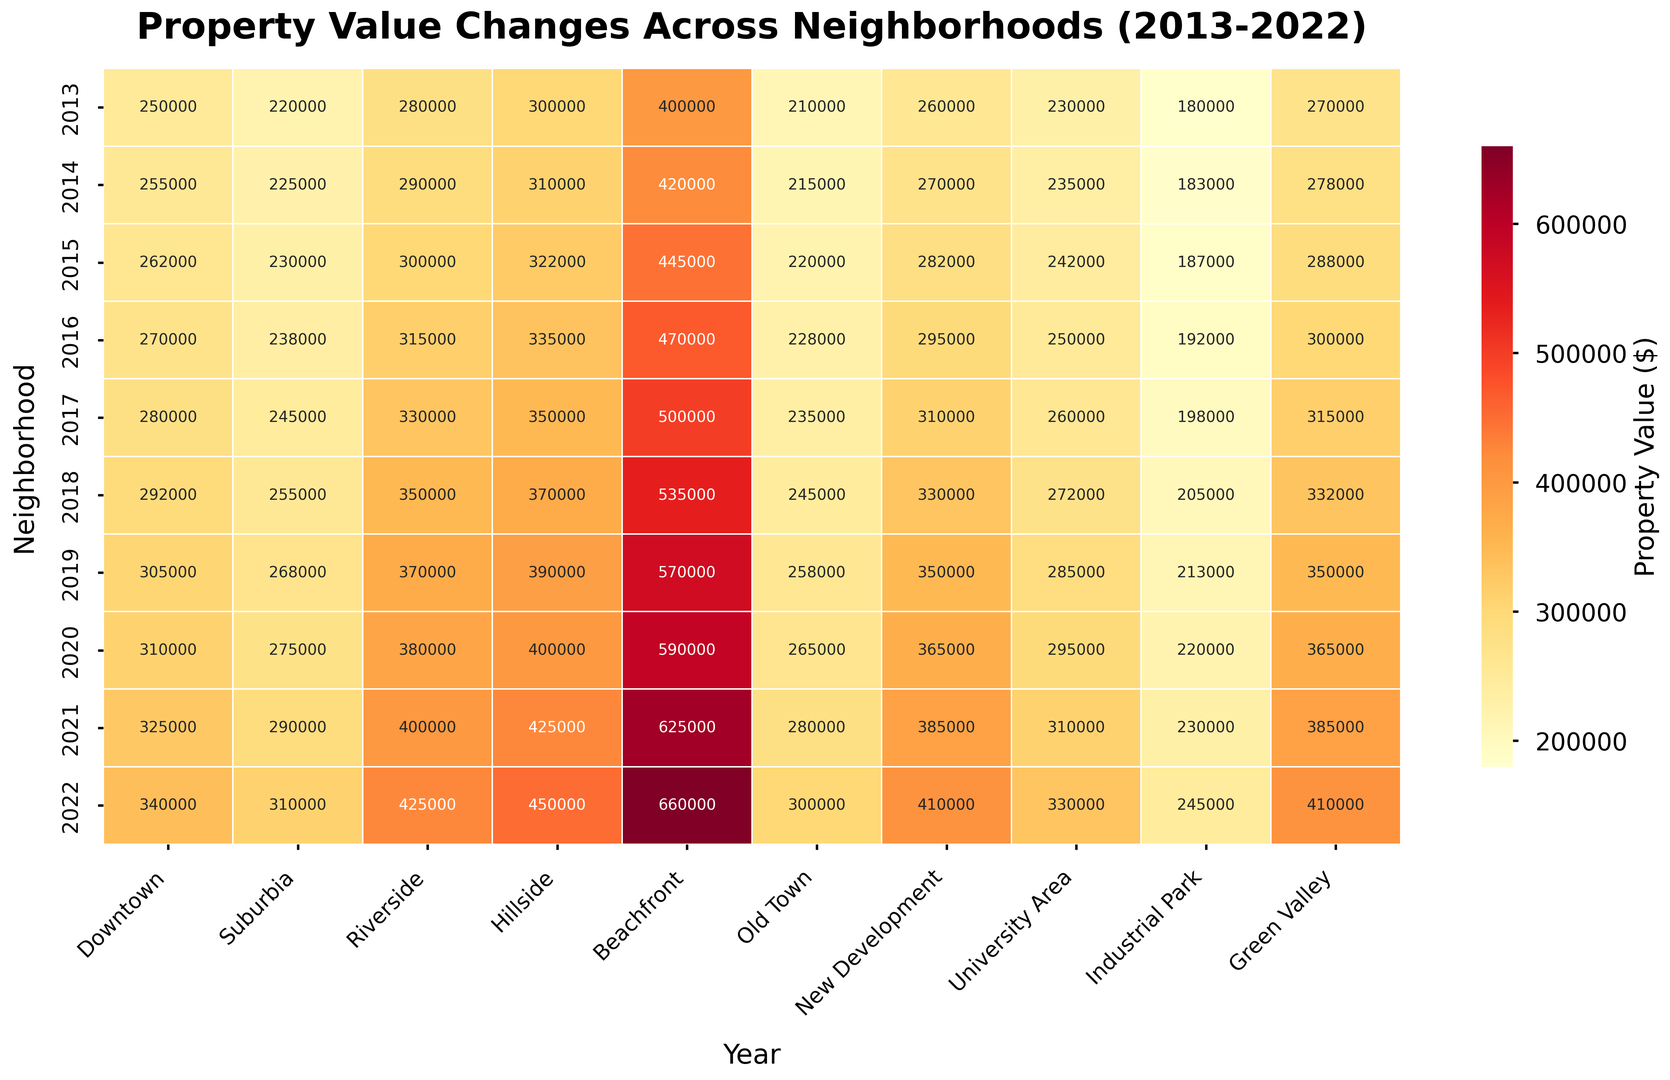What was the property value in Downtown in 2017? Look at the intersection of Downtown (y-axis) and 2017 (x-axis) on the heatmap. The value is 280,000.
Answer: 280,000 Between 2013 to 2022, which neighborhood had the largest increase in property value? Calculate the difference between 2022 and 2013 property values for each neighborhood. Beachfront has the largest increase: 660,000 - 400,000 = 260,000.
Answer: Beachfront In the year 2020, which neighborhood had the smallest property value? Examine the 2020 column for all neighborhoods. Industrial Park has the smallest value at 220,000.
Answer: Industrial Park Which neighborhoods had a property value of at least 400,000 in 2022? Look at the 2022 column and check which values are 400,000 or higher. They are Riverside, Hillside, Beachfront, and New Development.
Answer: Riverside, Hillside, Beachfront, New Development What was the average property value in Suburbia over the decade? Sum all values in Suburbia row: 220,000 + 225,000 + 230,000 + 238,000 + 245,000 + 255,000 + 268,000 + 275,000 + 290,000 + 310,000 = 2,556,000. Divide by 10 years to get the average: 2,556,000 / 10 = 255,600.
Answer: 255,600 Which neighborhood shows the least change in property value from 2018 to 2019? Calculate the difference for each neighborhood between 2018 and 2019. Industrial Park has the least change: 213,000 - 205,000 = 8,000.
Answer: Industrial Park By what percentage did property values increase in Downtown from 2013 to 2022? Calculate the percentage increase: ((340,000 - 250,000) / 250,000) * 100 = (90,000 / 250,000) * 100 = 36%.
Answer: 36% What's the combined property value for Beachfront and Hillside in 2015? Sum the values for Beachfront (445,000) and Hillside (322,000) in 2015: 445,000 + 322,000 = 767,000.
Answer: 767,000 Which neighborhood had the most consistent property value increase year over year? Identify the neighborhoods with consistent year-over-year increases. Beachfront shows a consistent increase each year without any exceptions.
Answer: Beachfront In 2017, which neighborhood had a property value closest to the City-wide average property value that same year? Calculate the City-wide average for 2017: (280,000 + 245,000 + 330,000 + 350,000 + 500,000 + 235,000 + 310,000 + 260,000 + 198,000 + 315,000) / 10 = 302,300. The closest neighborhood value is New Development at 310,000.
Answer: New Development 